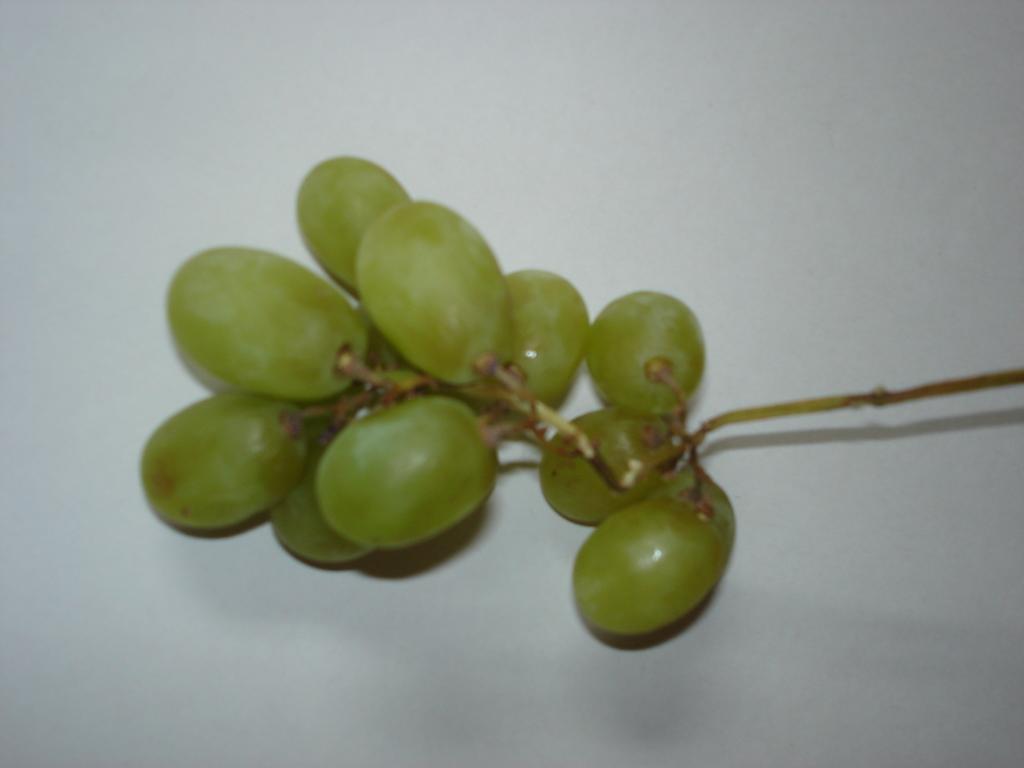Please provide a concise description of this image. In this picture we can see the bunch of grapes on the white object. 